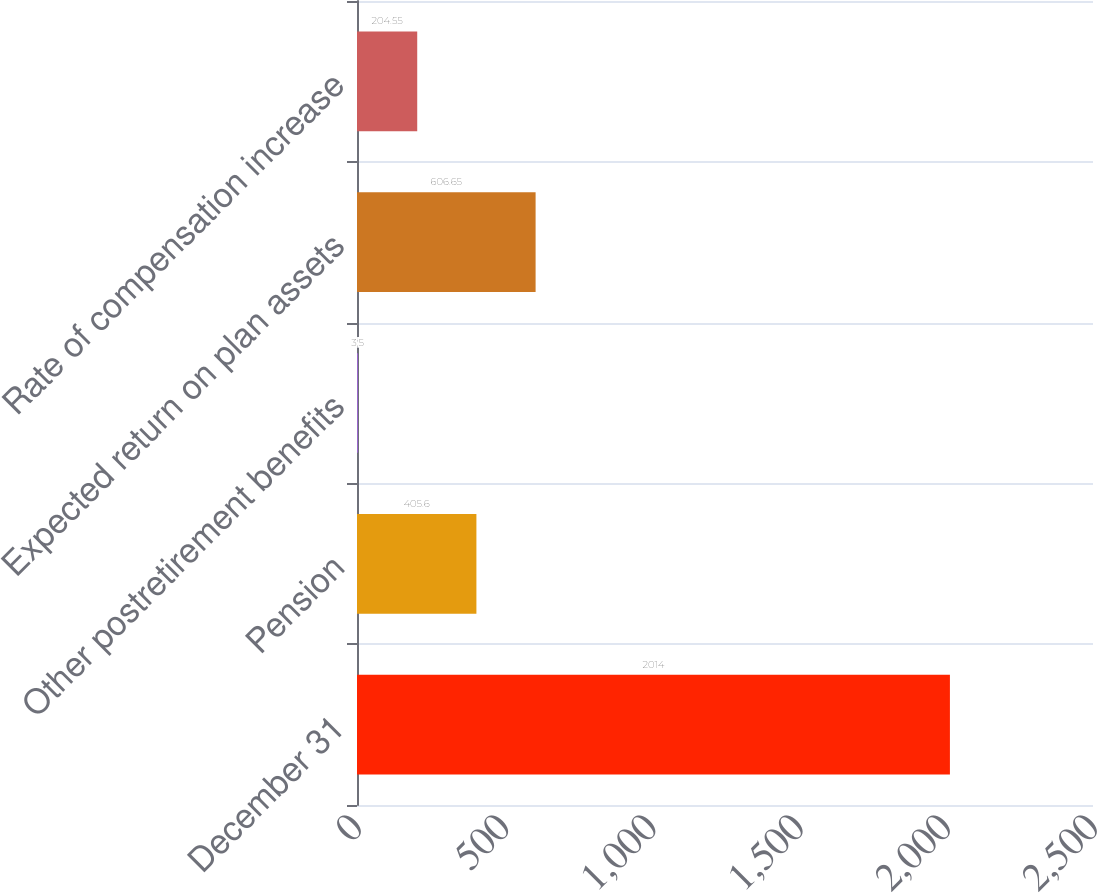Convert chart. <chart><loc_0><loc_0><loc_500><loc_500><bar_chart><fcel>December 31<fcel>Pension<fcel>Other postretirement benefits<fcel>Expected return on plan assets<fcel>Rate of compensation increase<nl><fcel>2014<fcel>405.6<fcel>3.5<fcel>606.65<fcel>204.55<nl></chart> 